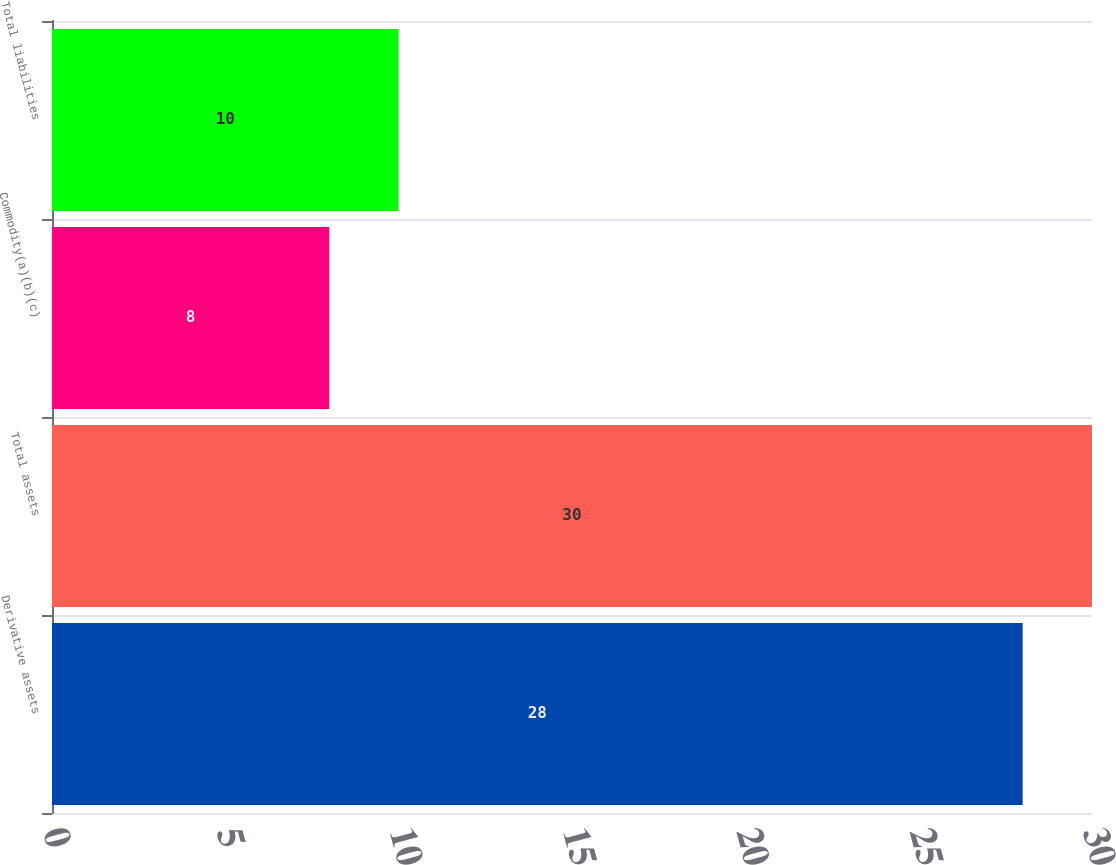<chart> <loc_0><loc_0><loc_500><loc_500><bar_chart><fcel>Derivative assets<fcel>Total assets<fcel>Commodity(a)(b)(c)<fcel>Total liabilities<nl><fcel>28<fcel>30<fcel>8<fcel>10<nl></chart> 